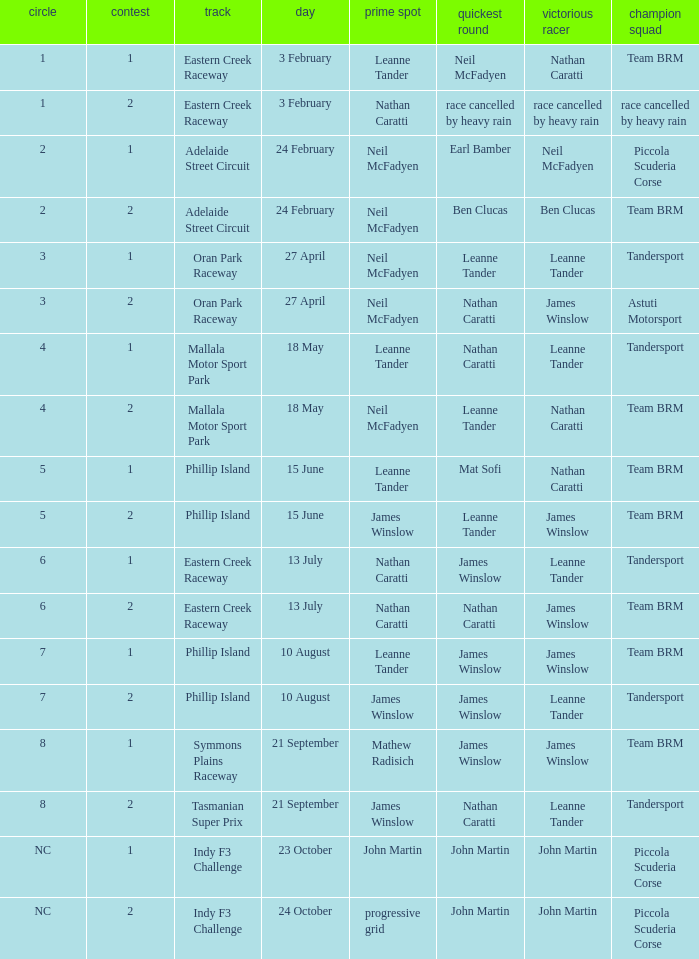What is the highest race number in the Phillip Island circuit with James Winslow as the winning driver and pole position? 2.0. 